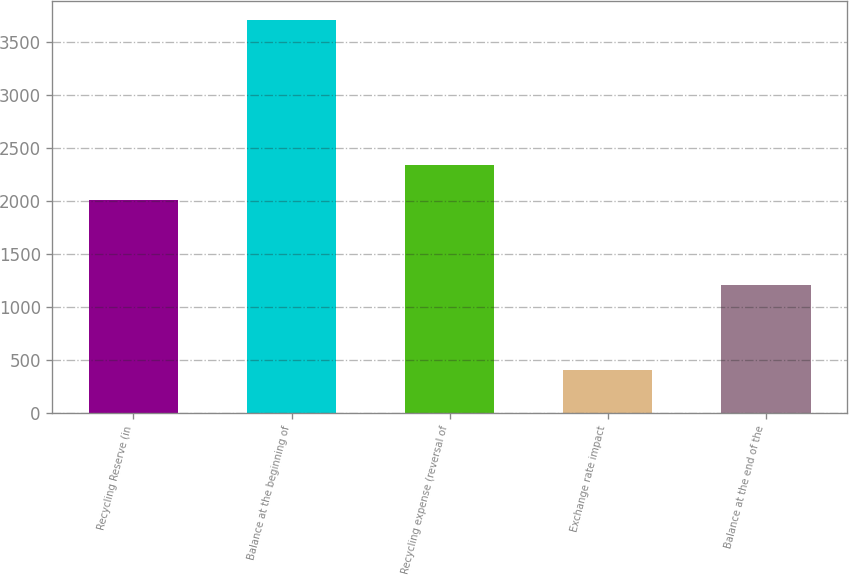Convert chart. <chart><loc_0><loc_0><loc_500><loc_500><bar_chart><fcel>Recycling Reserve (in<fcel>Balance at the beginning of<fcel>Recycling expense (reversal of<fcel>Exchange rate impact<fcel>Balance at the end of the<nl><fcel>2008<fcel>3706<fcel>2338.3<fcel>403<fcel>1207<nl></chart> 